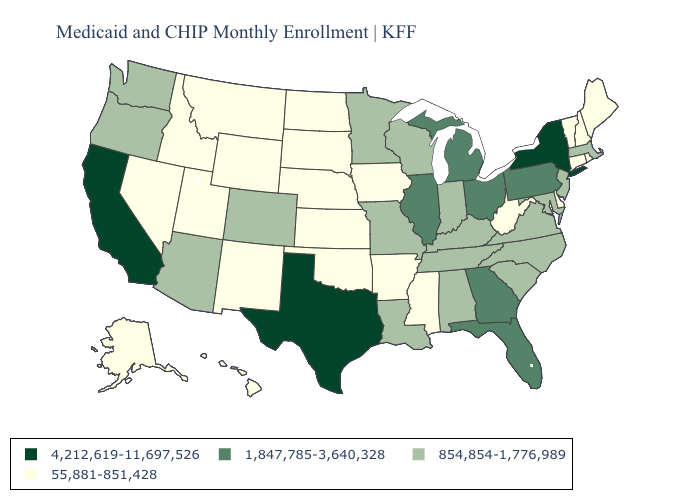What is the value of Alabama?
Give a very brief answer. 854,854-1,776,989. Name the states that have a value in the range 1,847,785-3,640,328?
Keep it brief. Florida, Georgia, Illinois, Michigan, Ohio, Pennsylvania. Does Michigan have the highest value in the MidWest?
Answer briefly. Yes. Among the states that border Oregon , does Nevada have the lowest value?
Concise answer only. Yes. What is the value of Michigan?
Be succinct. 1,847,785-3,640,328. What is the value of Nevada?
Write a very short answer. 55,881-851,428. Does the map have missing data?
Answer briefly. No. What is the lowest value in the USA?
Quick response, please. 55,881-851,428. Does New York have the highest value in the USA?
Be succinct. Yes. Name the states that have a value in the range 4,212,619-11,697,526?
Give a very brief answer. California, New York, Texas. Among the states that border New Hampshire , which have the lowest value?
Be succinct. Maine, Vermont. What is the lowest value in the USA?
Give a very brief answer. 55,881-851,428. What is the value of Rhode Island?
Concise answer only. 55,881-851,428. Name the states that have a value in the range 4,212,619-11,697,526?
Answer briefly. California, New York, Texas. How many symbols are there in the legend?
Quick response, please. 4. 